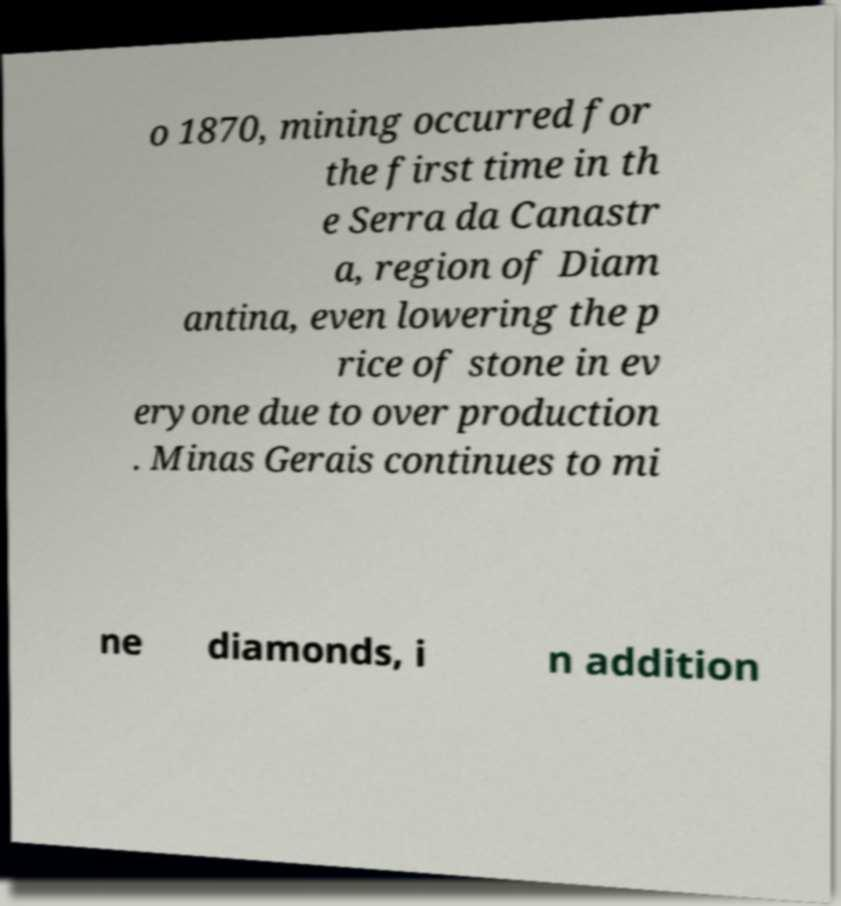For documentation purposes, I need the text within this image transcribed. Could you provide that? o 1870, mining occurred for the first time in th e Serra da Canastr a, region of Diam antina, even lowering the p rice of stone in ev eryone due to over production . Minas Gerais continues to mi ne diamonds, i n addition 